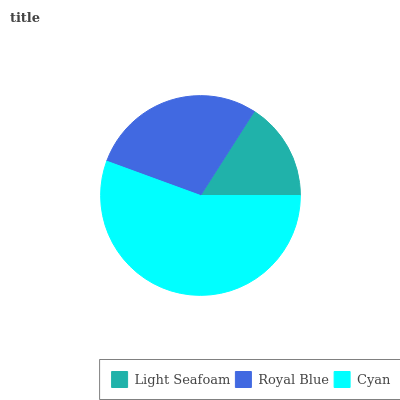Is Light Seafoam the minimum?
Answer yes or no. Yes. Is Cyan the maximum?
Answer yes or no. Yes. Is Royal Blue the minimum?
Answer yes or no. No. Is Royal Blue the maximum?
Answer yes or no. No. Is Royal Blue greater than Light Seafoam?
Answer yes or no. Yes. Is Light Seafoam less than Royal Blue?
Answer yes or no. Yes. Is Light Seafoam greater than Royal Blue?
Answer yes or no. No. Is Royal Blue less than Light Seafoam?
Answer yes or no. No. Is Royal Blue the high median?
Answer yes or no. Yes. Is Royal Blue the low median?
Answer yes or no. Yes. Is Light Seafoam the high median?
Answer yes or no. No. Is Cyan the low median?
Answer yes or no. No. 